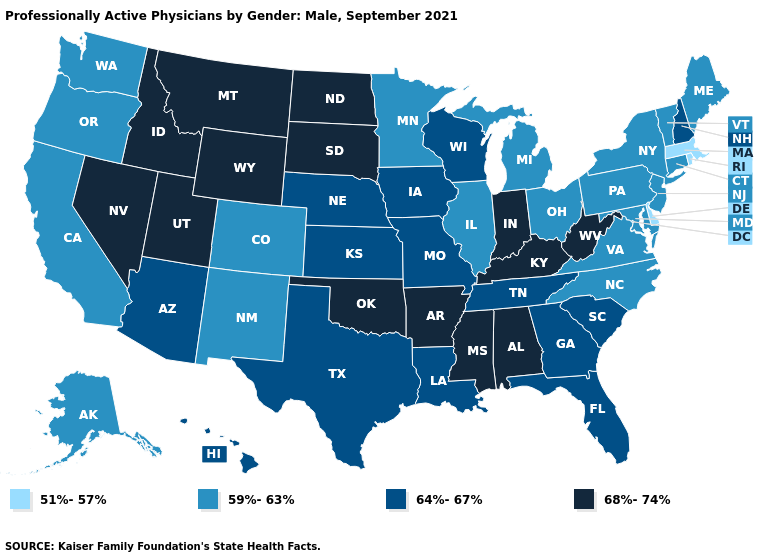Name the states that have a value in the range 68%-74%?
Keep it brief. Alabama, Arkansas, Idaho, Indiana, Kentucky, Mississippi, Montana, Nevada, North Dakota, Oklahoma, South Dakota, Utah, West Virginia, Wyoming. Which states have the highest value in the USA?
Keep it brief. Alabama, Arkansas, Idaho, Indiana, Kentucky, Mississippi, Montana, Nevada, North Dakota, Oklahoma, South Dakota, Utah, West Virginia, Wyoming. Among the states that border Indiana , which have the highest value?
Keep it brief. Kentucky. Does Nevada have the lowest value in the West?
Quick response, please. No. Name the states that have a value in the range 64%-67%?
Quick response, please. Arizona, Florida, Georgia, Hawaii, Iowa, Kansas, Louisiana, Missouri, Nebraska, New Hampshire, South Carolina, Tennessee, Texas, Wisconsin. Does Montana have a higher value than Oklahoma?
Keep it brief. No. What is the highest value in the USA?
Short answer required. 68%-74%. What is the value of Colorado?
Answer briefly. 59%-63%. Does New Hampshire have the highest value in the Northeast?
Quick response, please. Yes. Name the states that have a value in the range 64%-67%?
Write a very short answer. Arizona, Florida, Georgia, Hawaii, Iowa, Kansas, Louisiana, Missouri, Nebraska, New Hampshire, South Carolina, Tennessee, Texas, Wisconsin. Name the states that have a value in the range 68%-74%?
Quick response, please. Alabama, Arkansas, Idaho, Indiana, Kentucky, Mississippi, Montana, Nevada, North Dakota, Oklahoma, South Dakota, Utah, West Virginia, Wyoming. Name the states that have a value in the range 64%-67%?
Keep it brief. Arizona, Florida, Georgia, Hawaii, Iowa, Kansas, Louisiana, Missouri, Nebraska, New Hampshire, South Carolina, Tennessee, Texas, Wisconsin. Name the states that have a value in the range 51%-57%?
Answer briefly. Delaware, Massachusetts, Rhode Island. Name the states that have a value in the range 68%-74%?
Answer briefly. Alabama, Arkansas, Idaho, Indiana, Kentucky, Mississippi, Montana, Nevada, North Dakota, Oklahoma, South Dakota, Utah, West Virginia, Wyoming. What is the value of Minnesota?
Quick response, please. 59%-63%. 